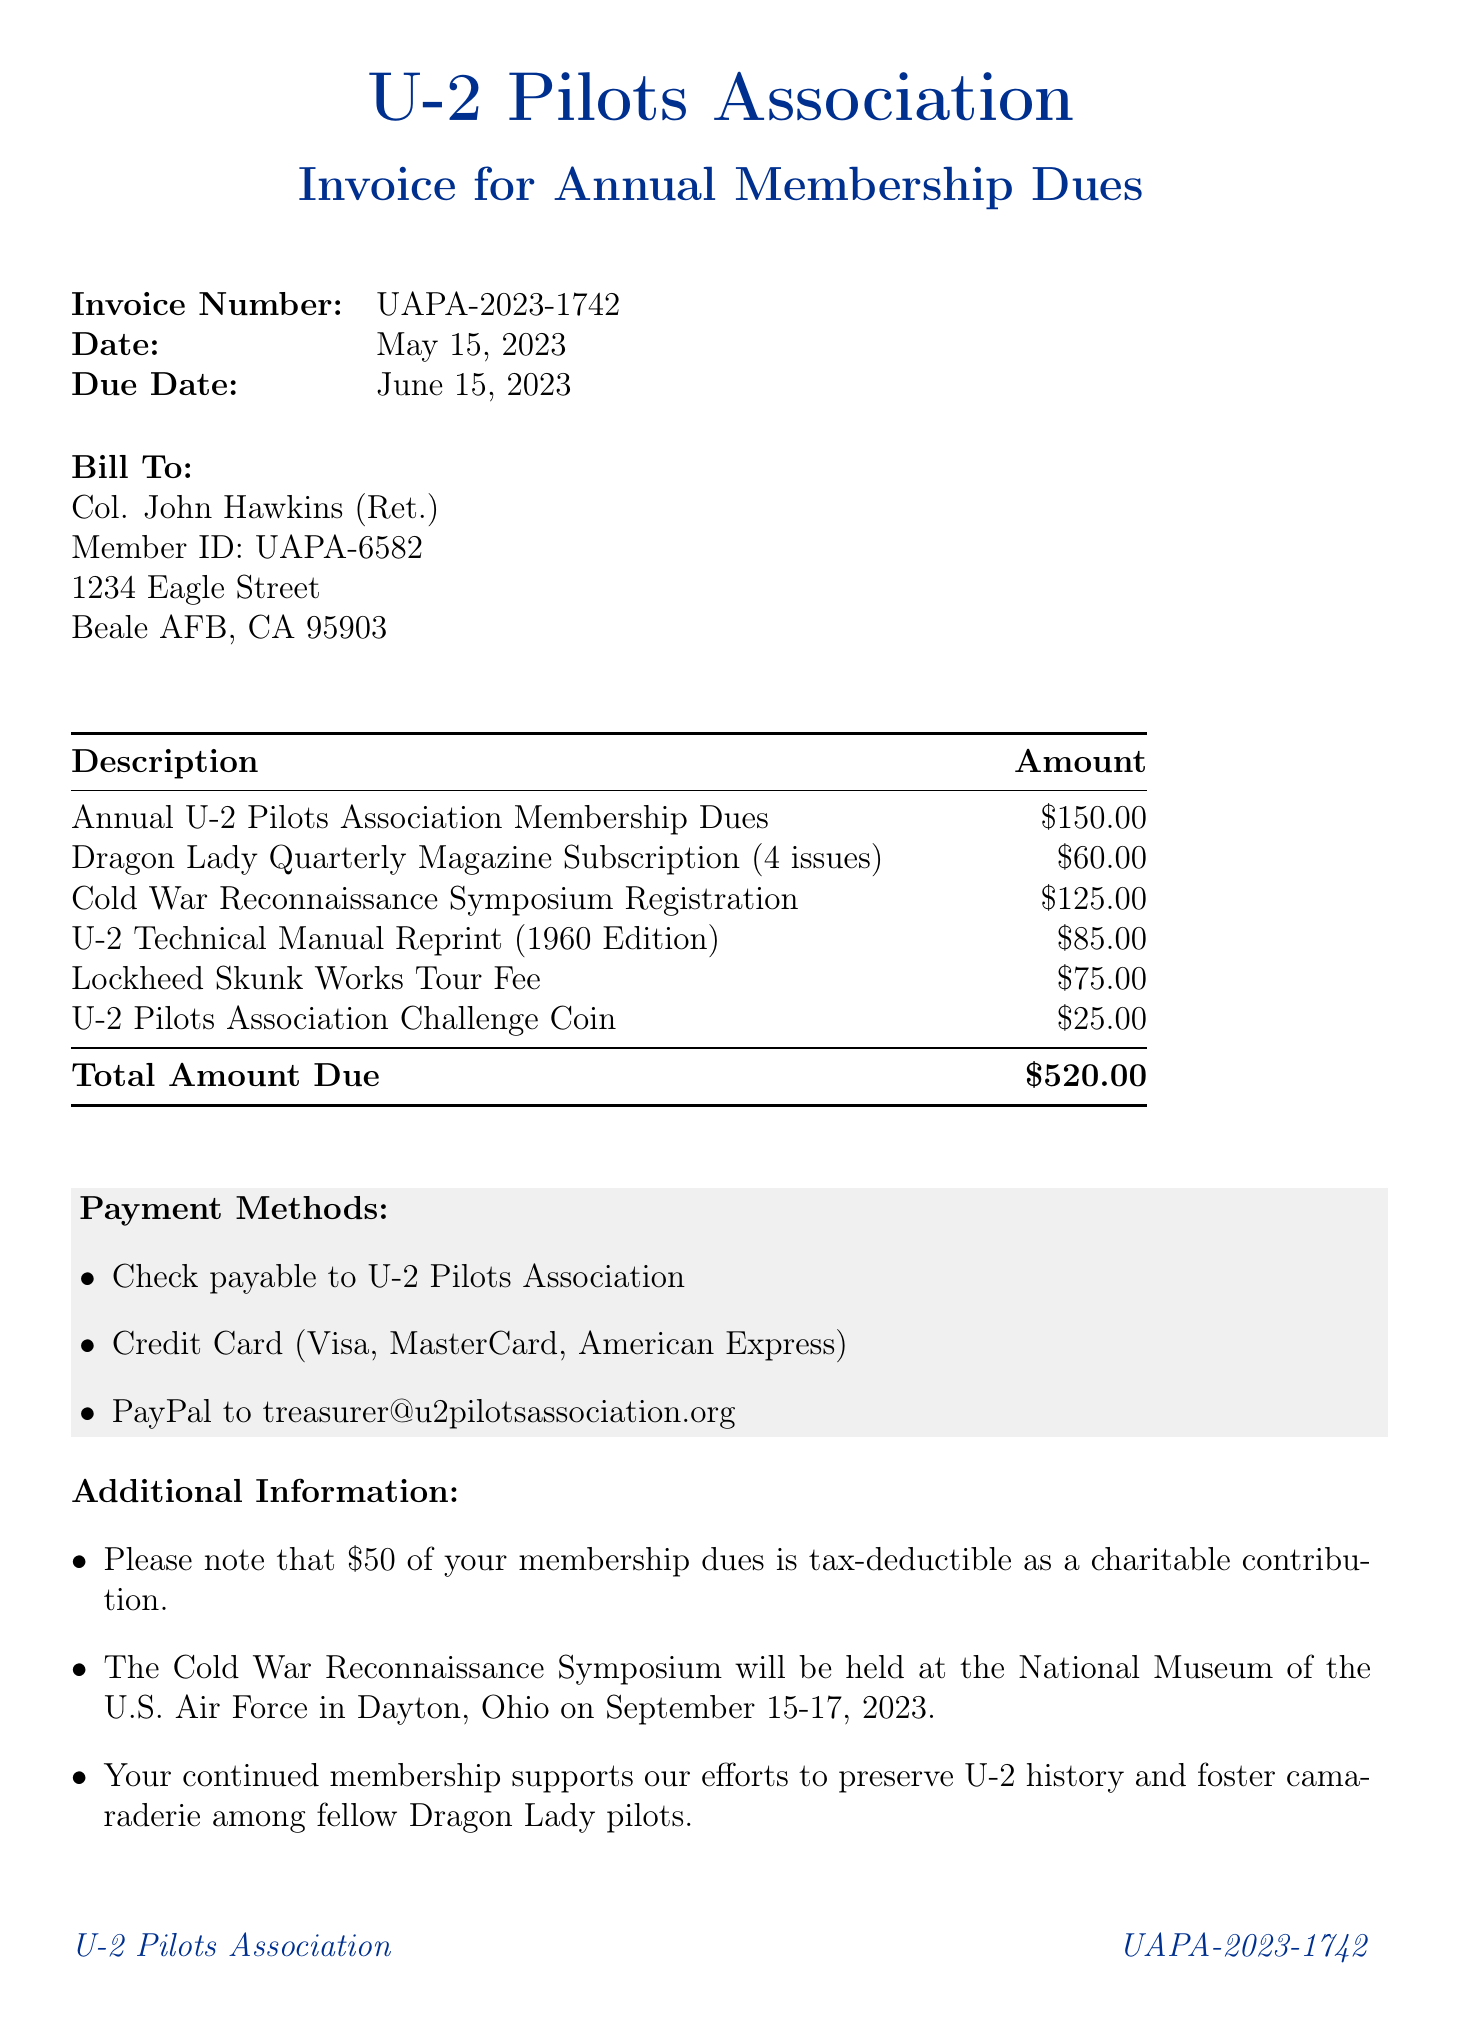What is the invoice number? The invoice number is a unique identifier for the document, found at the top of the invoice.
Answer: UAPA-2023-1742 What is the total amount due? The total amount due is listed at the bottom of the invoice and represents the cumulative fees.
Answer: $520.00 Who is the member named in the invoice? The member's name is specified under the billing section of the invoice.
Answer: Col. John Hawkins (Ret.) What is the due date for the payment? The due date signifies when the payment must be made, as listed on the invoice.
Answer: June 15, 2023 How much is the subscription for the Dragon Lady Quarterly Magazine? This amount can be found as part of the itemized breakdown on the invoice.
Answer: $60.00 How many issues are included in the magazine subscription? The number of issues for the magazine subscription is specified in the description on the invoice.
Answer: 4 issues Is any part of the membership dues tax-deductible? This information is highlighted in the additional information section regarding the dues.
Answer: Yes, $50 What payment methods are accepted? This information is listed in a designated section of the invoice outlining the various payment options.
Answer: Check, Credit Card, PayPal When will the Cold War Reconnaissance Symposium be held? The date is provided in the additional information section of the invoice.
Answer: September 15-17, 2023 